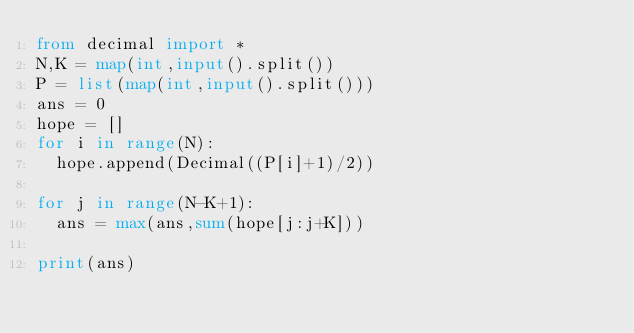Convert code to text. <code><loc_0><loc_0><loc_500><loc_500><_Python_>from decimal import *
N,K = map(int,input().split())
P = list(map(int,input().split()))
ans = 0
hope = []
for i in range(N):
  hope.append(Decimal((P[i]+1)/2))

for j in range(N-K+1):
  ans = max(ans,sum(hope[j:j+K]))

print(ans)</code> 